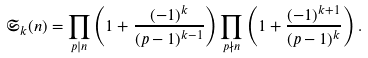Convert formula to latex. <formula><loc_0><loc_0><loc_500><loc_500>\mathfrak S _ { k } ( n ) = \prod _ { p | n } \left ( 1 + \frac { ( - 1 ) ^ { k } } { ( p - 1 ) ^ { k - 1 } } \right ) \prod _ { p \nmid n } \left ( 1 + \frac { ( - 1 ) ^ { k + 1 } } { ( p - 1 ) ^ { k } } \right ) .</formula> 